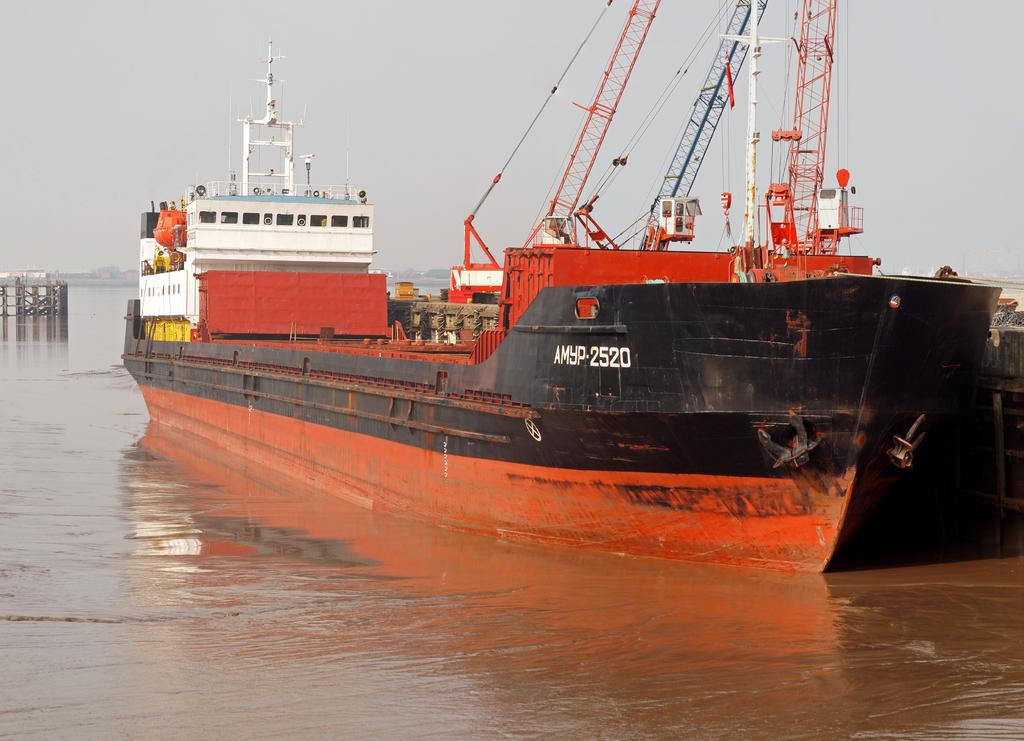What is the main subject of the image? The main subject of the image is a ship. Where is the ship located? The ship is on the water. What structures can be seen on the ship? There are poles, pillars, grills, and ropes on the ship. What else is on the ship? There are goods on the ship. What can be seen in the background of the image? The sky is visible in the background of the image. What type of thread is being used to sew the key onto the ship's sail in the image? There is no thread or key present in the image; the ship has ropes and goods, but no thread or key. 